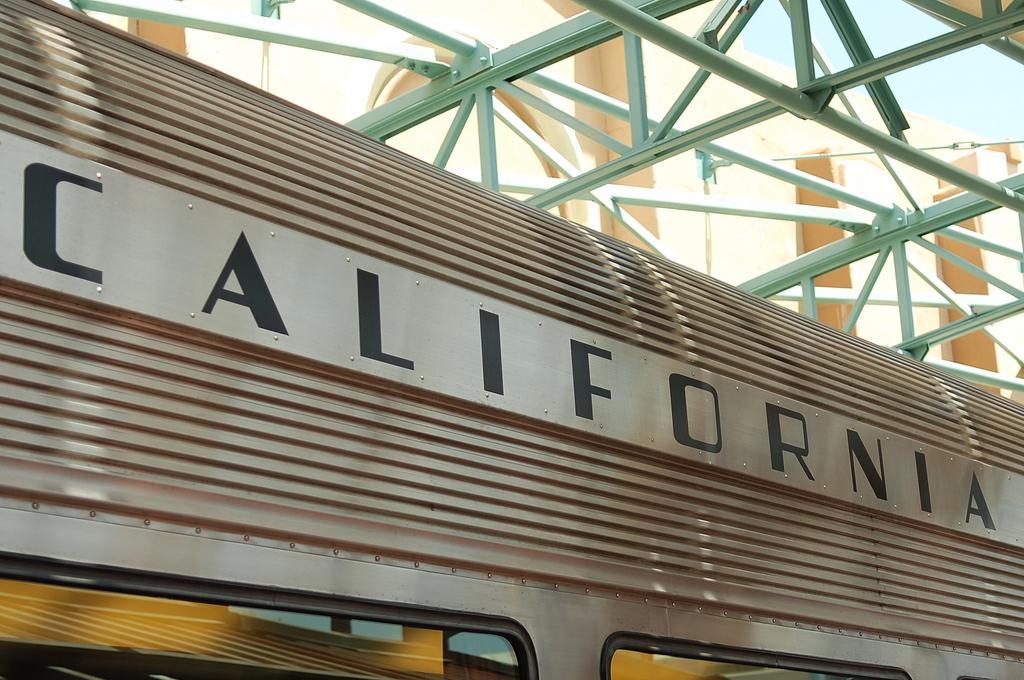How would you summarize this image in a sentence or two? This picture looks like a train and I can see text on it and I can see a building and a blue cloudy sky. 